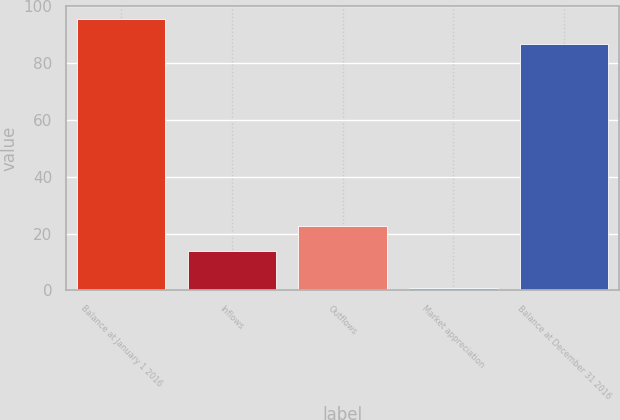Convert chart to OTSL. <chart><loc_0><loc_0><loc_500><loc_500><bar_chart><fcel>Balance at January 1 2016<fcel>Inflows<fcel>Outflows<fcel>Market appreciation<fcel>Balance at December 31 2016<nl><fcel>95.41<fcel>13.8<fcel>22.61<fcel>0.9<fcel>86.6<nl></chart> 